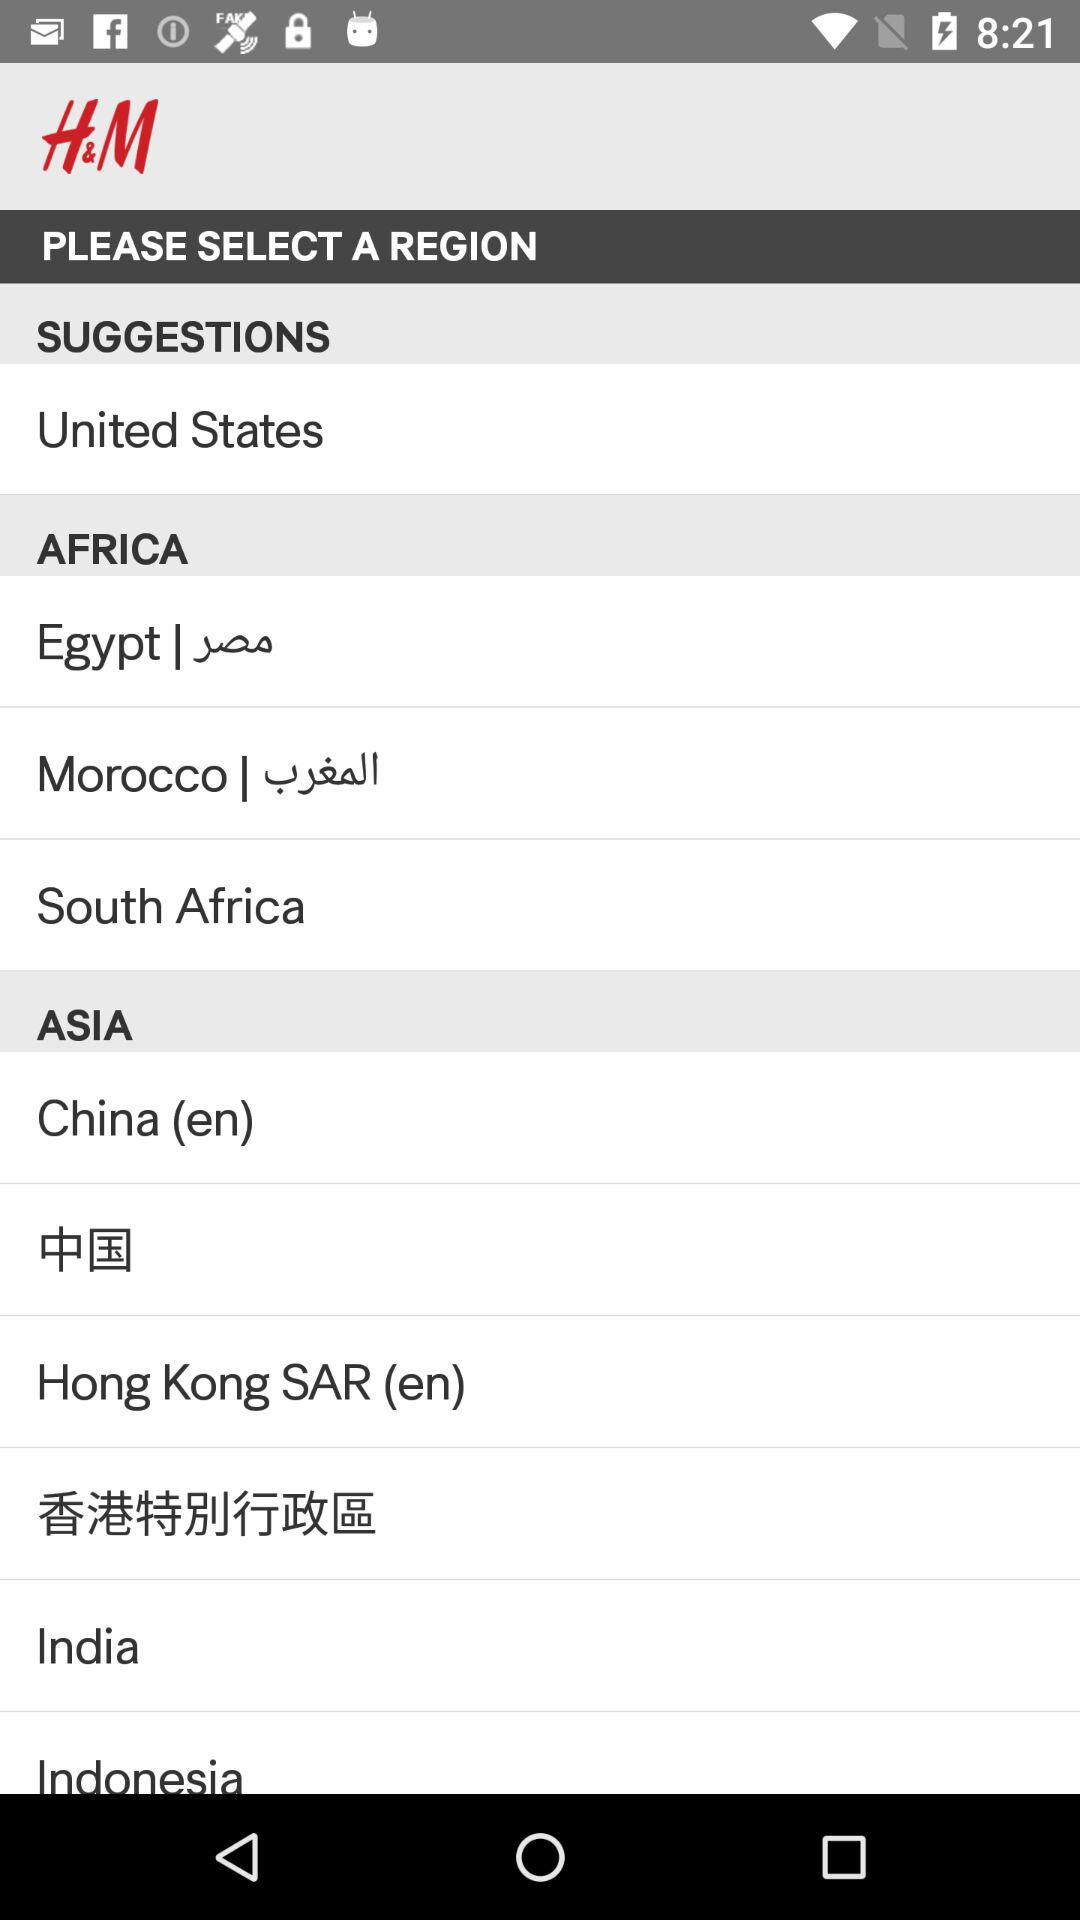What is the suggested country? The suggested country is the United States. 